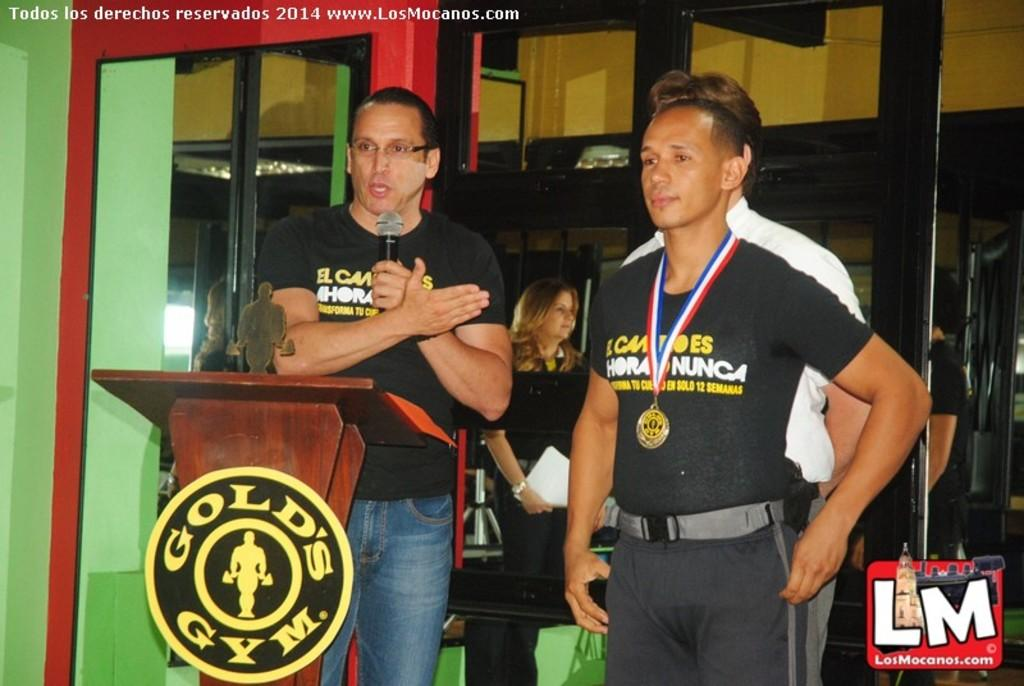<image>
Share a concise interpretation of the image provided. A man stands at a podium that says Gold's Gym on the front. 